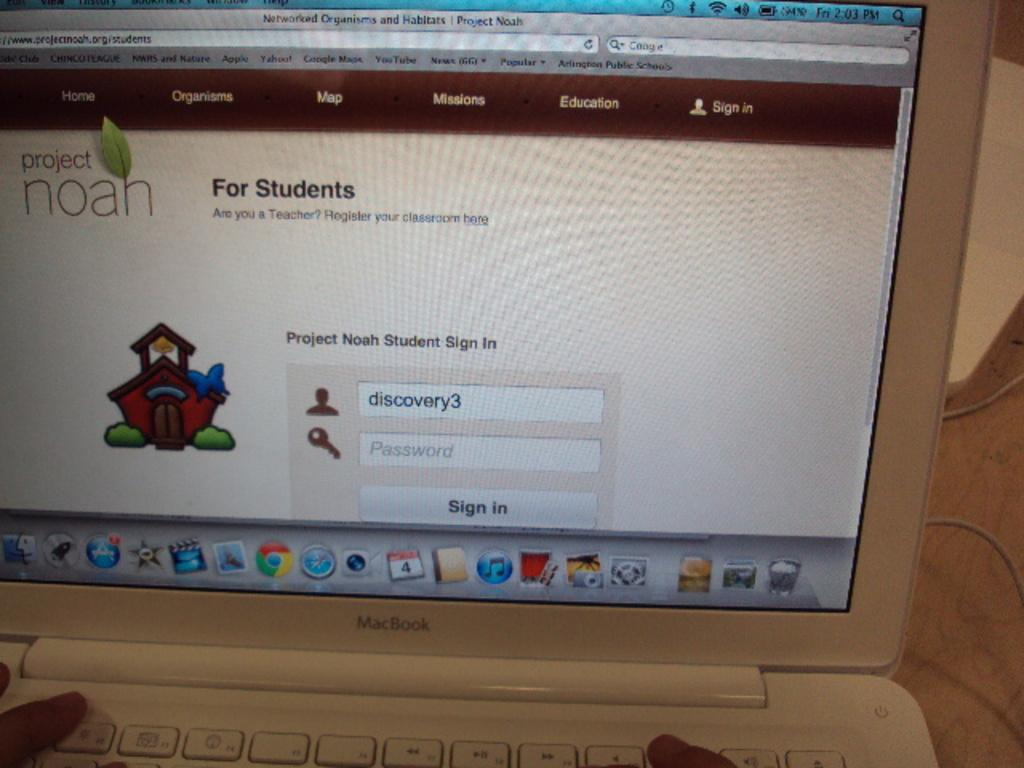<image>
Give a short and clear explanation of the subsequent image. The sign in page of the Project Noah site is displayed on a MacBook computer. 